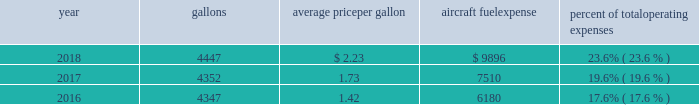The table shows annual aircraft fuel consumption and costs , including taxes , for our mainline and regional operations for 2018 , 2017 and 2016 ( gallons and aircraft fuel expense in millions ) .
Year gallons average price per gallon aircraft fuel expense percent of total operating expenses .
As of december 31 , 2018 , we did not have any fuel hedging contracts outstanding to hedge our fuel consumption .
As such , and assuming we do not enter into any future transactions to hedge our fuel consumption , we will continue to be fully exposed to fluctuations in fuel prices .
Our current policy is not to enter into transactions to hedge our fuel consumption , although we review that policy from time to time based on market conditions and other factors .
Fuel prices have fluctuated substantially over the past several years .
We cannot predict the future availability , price volatility or cost of aircraft fuel .
Natural disasters ( including hurricanes or similar events in the u.s .
Southeast and on the gulf coast where a significant portion of domestic refining capacity is located ) , political disruptions or wars involving oil-producing countries , economic sanctions imposed against oil-producing countries or specific industry participants , changes in fuel-related governmental policy , the strength of the u.s .
Dollar against foreign currencies , changes in the cost to transport or store petroleum products , changes in access to petroleum product pipelines and terminals , speculation in the energy futures markets , changes in aircraft fuel production capacity , environmental concerns and other unpredictable events may result in fuel supply shortages , distribution challenges , additional fuel price volatility and cost increases in the future .
See part i , item 1a .
Risk factors 2013 201cour business is very dependent on the price and availability of aircraft fuel .
Continued periods of high volatility in fuel costs , increased fuel prices or significant disruptions in the supply of aircraft fuel could have a significant negative impact on our operating results and liquidity . 201d seasonality and other factors due to the greater demand for air travel during the summer months , revenues in the airline industry in the second and third quarters of the year tend to be greater than revenues in the first and fourth quarters of the year .
General economic conditions , fears of terrorism or war , fare initiatives , fluctuations in fuel prices , labor actions , weather , natural disasters , outbreaks of disease and other factors could impact this seasonal pattern .
Therefore , our quarterly results of operations are not necessarily indicative of operating results for the entire year , and historical operating results in a quarterly or annual period are not necessarily indicative of future operating results .
Domestic and global regulatory landscape general airlines are subject to extensive domestic and international regulatory requirements .
Domestically , the dot and the federal aviation administration ( faa ) exercise significant regulatory authority over air carriers .
The dot , among other things , oversees domestic and international codeshare agreements , international route authorities , competition and consumer protection matters such as advertising , denied boarding compensation and baggage liability .
The antitrust division of the department of justice ( doj ) , along with the dot in certain instances , have jurisdiction over airline antitrust matters. .
What was the total operating expenses in 2018 in millions? 
Rationale: the total operating expenses is obtained by dividing the fuel expenses$ by the percent of operating expenses
Computations: (9896 / 23.6%)
Answer: 41932.20339. 